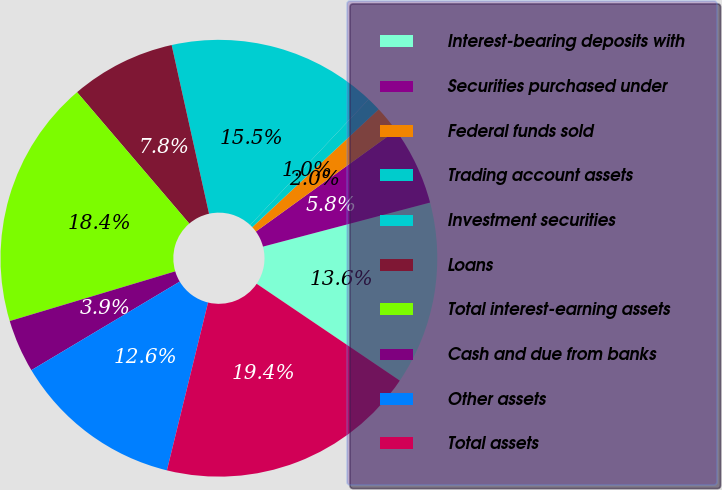Convert chart. <chart><loc_0><loc_0><loc_500><loc_500><pie_chart><fcel>Interest-bearing deposits with<fcel>Securities purchased under<fcel>Federal funds sold<fcel>Trading account assets<fcel>Investment securities<fcel>Loans<fcel>Total interest-earning assets<fcel>Cash and due from banks<fcel>Other assets<fcel>Total assets<nl><fcel>13.57%<fcel>5.85%<fcel>1.99%<fcel>1.03%<fcel>15.5%<fcel>7.78%<fcel>18.39%<fcel>3.92%<fcel>12.61%<fcel>19.36%<nl></chart> 